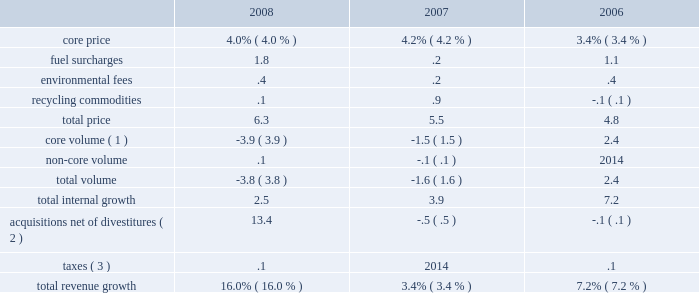Increased by $ 105.6 million , or 3.4% ( 3.4 % ) , from 2006 to 2007 .
The table reflects the components of our revenue growth for the years ended december 31 , 2008 , 2007 and 2006: .
( 1 ) core volume growth for the year ended december 31 , 2006 includes .8% ( .8 % ) associated with hauling waste from the city of toronto to one of our landfills in michigan .
This hauling service is provided to the city at a rate that approximates our cost .
( 2 ) includes the impact of the acquisition of allied in december 2008 .
( 3 ) represents new taxes levied on landfill volumes in certain states that are passed on to customers .
25aa 2008 : during the year ended december 31 , 2008 , our core revenue growth continued to benefit from a broad-based pricing initiative .
In addition , 14.7% ( 14.7 % ) of our revenue growth is due to our acquisition of allied in december 2008 .
Revenue growth also benefited from higher fuel surcharges and environmental fees .
However , during 2008 we experienced lower prices for commodities .
We also experienced a decrease in core volumes primarily due to lower commercial and industrial collection volumes and lower landfill volumes resulting from the slowdown in the economy .
We expect to continue to experience lower volumes until economic conditions improve .
25aa 2007 : during the year ended december 31 , 2007 , our revenue growth from core pricing continued to benefit from a broad-based pricing initiative .
Our revenue growth also benefited from higher prices for commodities .
However , we experienced a decrease in core volume growth primarily due to lower industrial collection and landfill volumes resulting from the slowdown in residential construction .
25aa 2006 : during the year ended december 31 , 2006 , our revenue growth continued to benefit from our broad-based pricing initiative .
We experienced core volume growth in our collection and landfill lines of business .
This core volume growth was partially offset by hurricane clean-up efforts that took place during the fourth quarter of 2005 .
25aa 2009 outlook : we anticipate internal revenue from core operations to decrease approximately 4.0% ( 4.0 % ) during 2009 .
This decrease is the expected net of growth in core pricing of approximately 4.0% ( 4.0 % ) and an expected decrease in volume of approximately 8.0% ( 8.0 % ) .
Our projections assume no deterioration or improvement in the overall economy from that experienced during the fourth quarter of 2008 .
However , our internal growth may remain flat or may decline in 2009 depending on economic conditions and our success in implementing pricing initiatives .
Cost of operations .
Cost of operations was $ 2.4 billion , $ 2.0 billion and $ 1.9 billion , or , as a percentage of revenue , 65.6% ( 65.6 % ) , 63.1% ( 63.1 % ) and 62.7% ( 62.7 % ) , for the years ended december 31 , 2008 , 2007 and 2006 , respectively .
The increase in cost of operations in aggregate dollars for the year ended december 31 , 2008 versus the comparable 2007 period is primarily a result of our acquisition of allied in december 2008 .
The remaining increase in cost of operations in aggregate dollars and the increase as a percentage of revenue is primarily due to charges we recorded during 2008 of $ 98.0 million related to estimated costs to comply with f&os issued by the oepa and the aoc issued by the epa in response to environmental conditions at our countywide facility in ohio , $ 21.9 million related to environmental conditions at our closed disposal facility %%transmsg*** transmitting job : p14076 pcn : 048000000 ***%%pcmsg|46 |00044|yes|no|02/28/2009 17:08|0|0|page is valid , no graphics -- color : d| .
What was the average cost of operations from 2006 to 2008 in millions? 
Computations: (((2.4 + 2.0) + 1.9) / 3)
Answer: 2.1. 